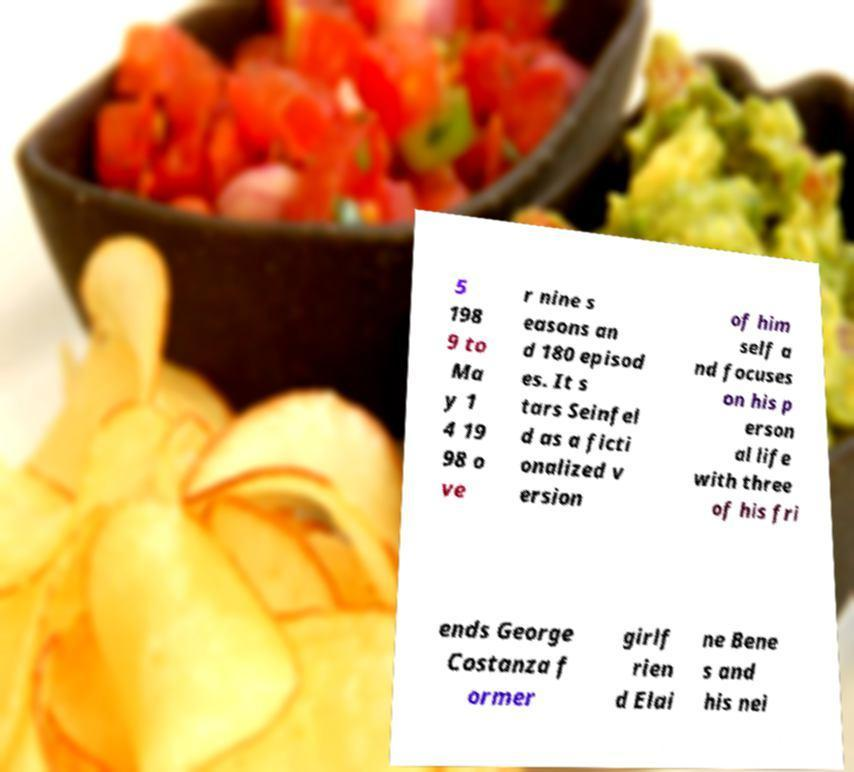For documentation purposes, I need the text within this image transcribed. Could you provide that? 5 198 9 to Ma y 1 4 19 98 o ve r nine s easons an d 180 episod es. It s tars Seinfel d as a ficti onalized v ersion of him self a nd focuses on his p erson al life with three of his fri ends George Costanza f ormer girlf rien d Elai ne Bene s and his nei 